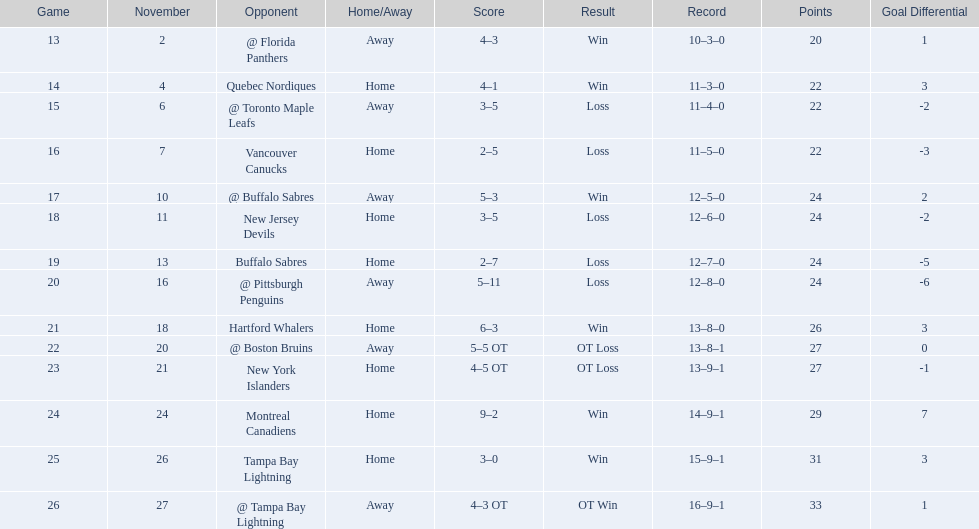Did the tampa bay lightning have the lowest count of wins? Yes. 